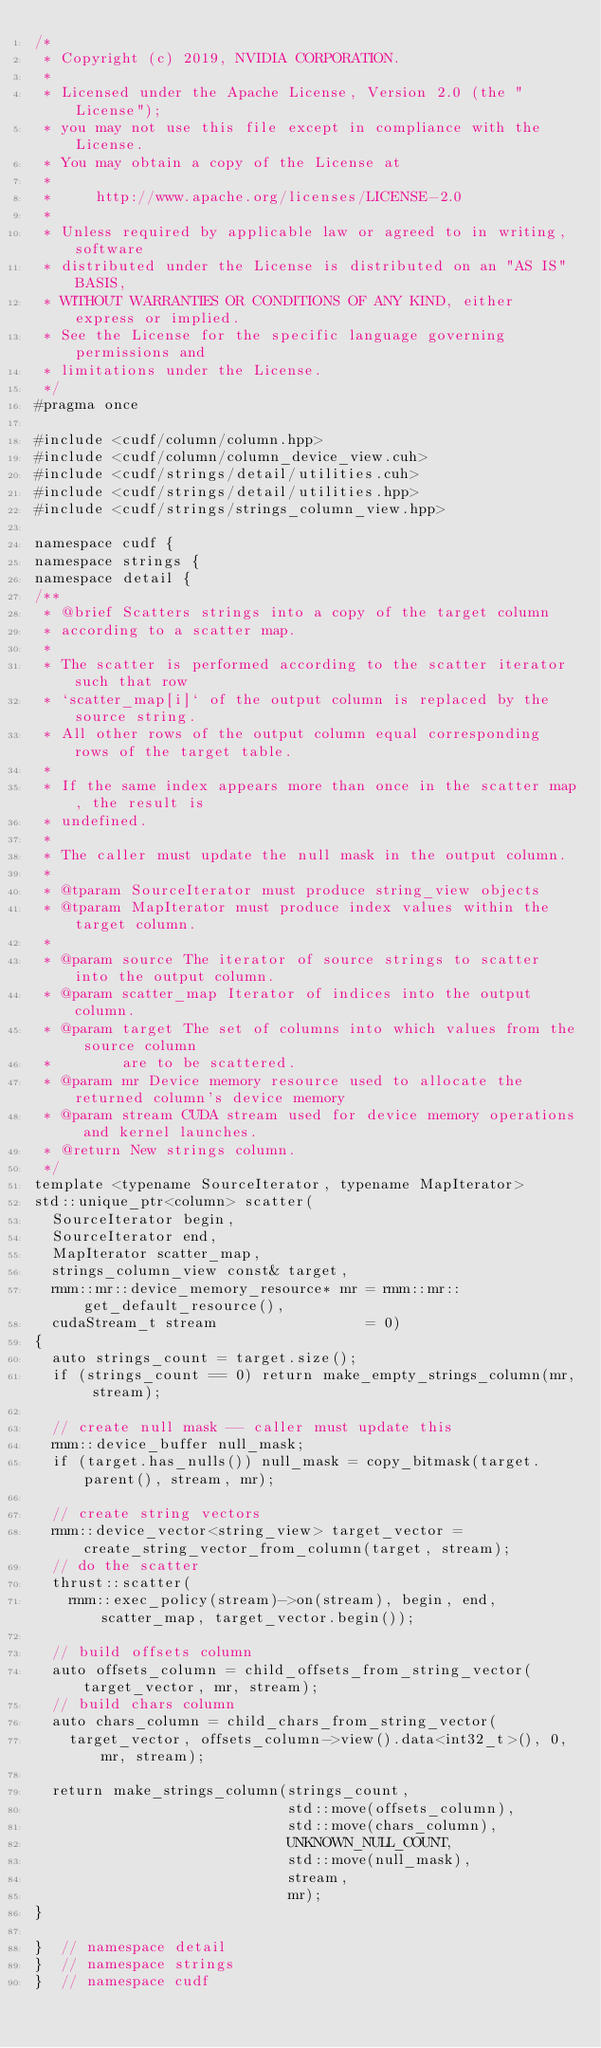<code> <loc_0><loc_0><loc_500><loc_500><_Cuda_>/*
 * Copyright (c) 2019, NVIDIA CORPORATION.
 *
 * Licensed under the Apache License, Version 2.0 (the "License");
 * you may not use this file except in compliance with the License.
 * You may obtain a copy of the License at
 *
 *     http://www.apache.org/licenses/LICENSE-2.0
 *
 * Unless required by applicable law or agreed to in writing, software
 * distributed under the License is distributed on an "AS IS" BASIS,
 * WITHOUT WARRANTIES OR CONDITIONS OF ANY KIND, either express or implied.
 * See the License for the specific language governing permissions and
 * limitations under the License.
 */
#pragma once

#include <cudf/column/column.hpp>
#include <cudf/column/column_device_view.cuh>
#include <cudf/strings/detail/utilities.cuh>
#include <cudf/strings/detail/utilities.hpp>
#include <cudf/strings/strings_column_view.hpp>

namespace cudf {
namespace strings {
namespace detail {
/**
 * @brief Scatters strings into a copy of the target column
 * according to a scatter map.
 *
 * The scatter is performed according to the scatter iterator such that row
 * `scatter_map[i]` of the output column is replaced by the source string.
 * All other rows of the output column equal corresponding rows of the target table.
 *
 * If the same index appears more than once in the scatter map, the result is
 * undefined.
 *
 * The caller must update the null mask in the output column.
 *
 * @tparam SourceIterator must produce string_view objects
 * @tparam MapIterator must produce index values within the target column.
 *
 * @param source The iterator of source strings to scatter into the output column.
 * @param scatter_map Iterator of indices into the output column.
 * @param target The set of columns into which values from the source column
 *        are to be scattered.
 * @param mr Device memory resource used to allocate the returned column's device memory
 * @param stream CUDA stream used for device memory operations and kernel launches.
 * @return New strings column.
 */
template <typename SourceIterator, typename MapIterator>
std::unique_ptr<column> scatter(
  SourceIterator begin,
  SourceIterator end,
  MapIterator scatter_map,
  strings_column_view const& target,
  rmm::mr::device_memory_resource* mr = rmm::mr::get_default_resource(),
  cudaStream_t stream                 = 0)
{
  auto strings_count = target.size();
  if (strings_count == 0) return make_empty_strings_column(mr, stream);

  // create null mask -- caller must update this
  rmm::device_buffer null_mask;
  if (target.has_nulls()) null_mask = copy_bitmask(target.parent(), stream, mr);

  // create string vectors
  rmm::device_vector<string_view> target_vector = create_string_vector_from_column(target, stream);
  // do the scatter
  thrust::scatter(
    rmm::exec_policy(stream)->on(stream), begin, end, scatter_map, target_vector.begin());

  // build offsets column
  auto offsets_column = child_offsets_from_string_vector(target_vector, mr, stream);
  // build chars column
  auto chars_column = child_chars_from_string_vector(
    target_vector, offsets_column->view().data<int32_t>(), 0, mr, stream);

  return make_strings_column(strings_count,
                             std::move(offsets_column),
                             std::move(chars_column),
                             UNKNOWN_NULL_COUNT,
                             std::move(null_mask),
                             stream,
                             mr);
}

}  // namespace detail
}  // namespace strings
}  // namespace cudf
</code> 